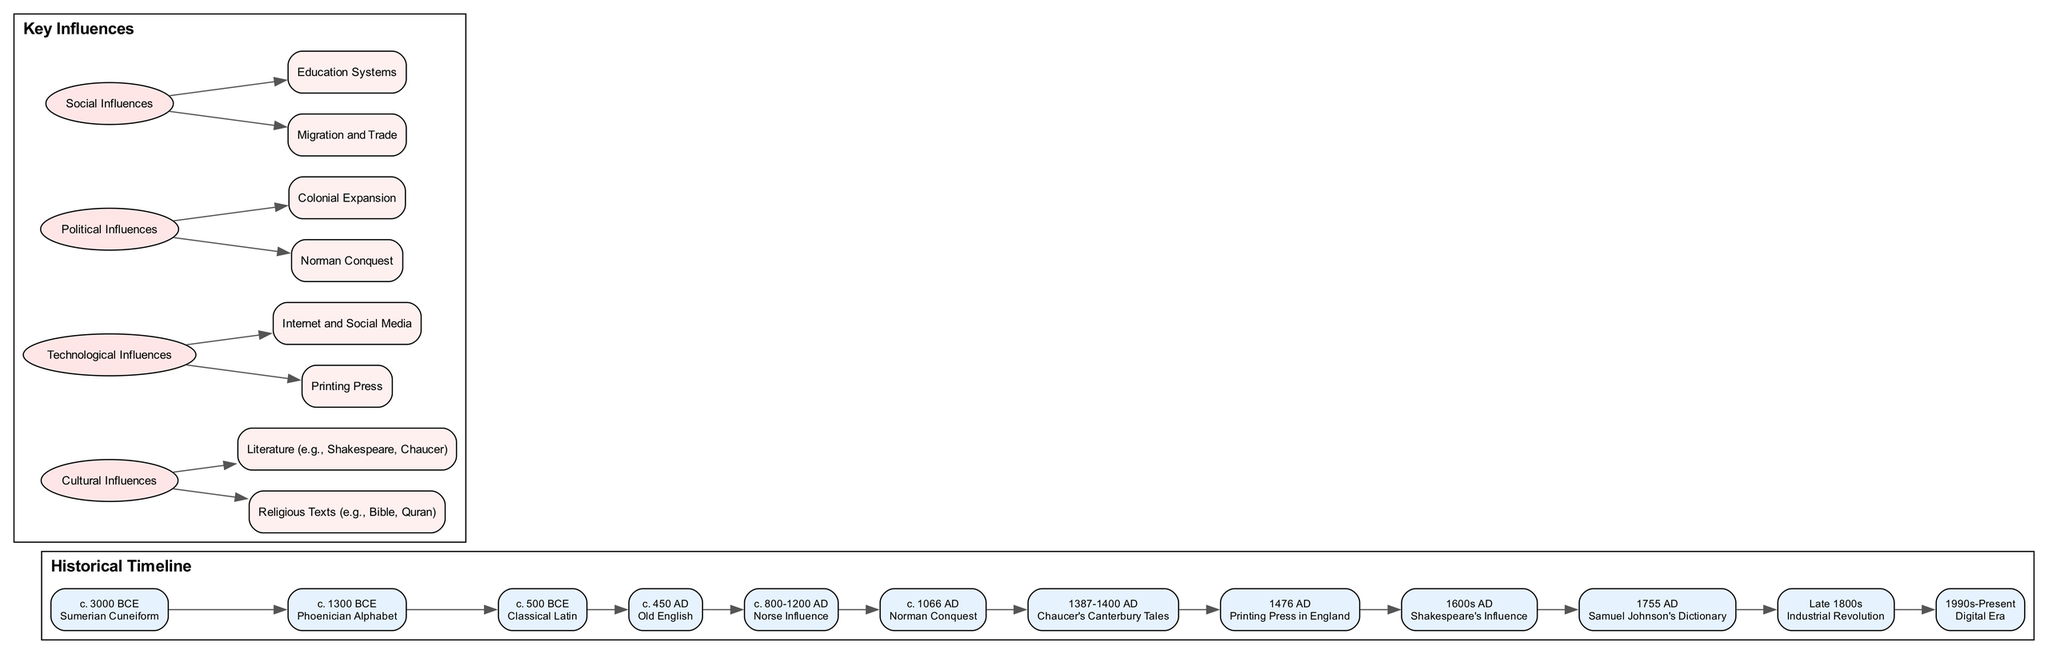What is the earliest writing system mentioned in the diagram? The diagram lists the first known writing system as "Sumerian Cuneiform," which is dated around c. 3000 BCE. This information is specifically stated in the timeline of events.
Answer: Sumerian Cuneiform How many key influences are identified in the diagram? The diagram categorizes key influences into four groups: Cultural Influences, Technological Influences, Political Influences, and Social Influences. Counting these categories gives a total of four.
Answer: 4 What year did the printing press get introduced in England? The diagram specifies that the printing press was introduced in England in the year 1476 AD, as indicated in the historical timeline.
Answer: 1476 AD Which event is represented immediately before the emergence of Old English? The event just before "Old English," which is dated c. 450 AD, is "Classical Latin," dated c. 500 BCE. By checking the connections in the timeline, we find that Old English follows Classical Latin.
Answer: Classical Latin Which historical figure is associated with the first comprehensive English dictionary? The diagram states that "Samuel Johnson" is the figure associated with the first comprehensive English dictionary released in 1755 AD. This is clearly indicated in the timeline events.
Answer: Samuel Johnson What impact did the Norse have on the English language? According to the diagram, the Norse influence, occurring between c. 800-1200 AD, impacted English vocabulary and grammar. The description specifically mentions this effect on the language.
Answer: Vocabulary and grammar Identify one example of a cultural influence listed in the diagram. The diagram lists "Religious Texts (e.g., Bible, Quran)" as an example of cultural influences on language. This is found under the Cultural Influences category in the diagram.
Answer: Religious Texts What significant literary work established Middle English as a literary language? The diagram identifies "Chaucer's Canterbury Tales," dated between 1387-1400 AD, as the work that established Middle English as a literary language, as stated in the timeline.
Answer: Chaucer's Canterbury Tales How did the Industrial Revolution influence language? The diagram notes that the Industrial Revolution led to new terminology to describe technological advancements, indicating a direct influence of this historical period on language development.
Answer: New terminology 